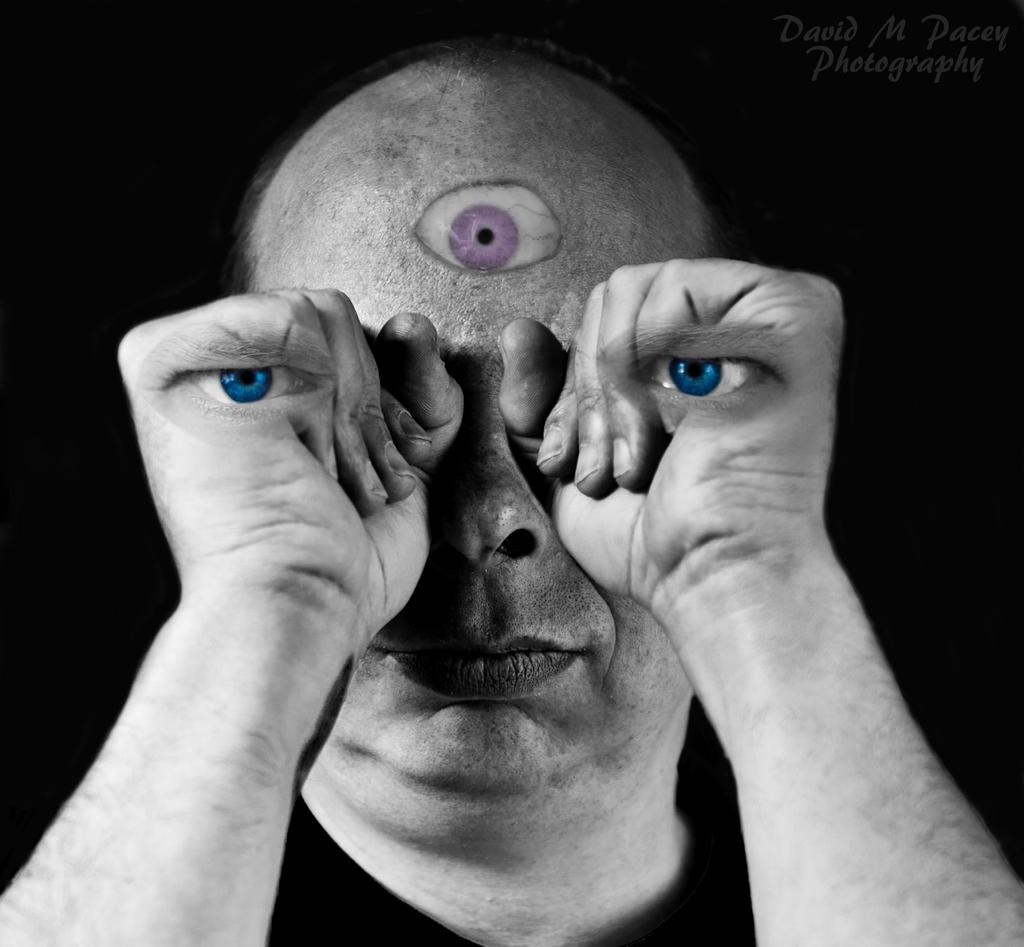What is the color scheme of the image? The image is black and white. Can you describe the person in the image? There is a man in the image. What is the man doing with his hand in the image? The man is holding his fist in front of his eye. What is an unusual feature on the man's forehead? There is an eye on the man's forehead. What is the connection between the man and the yak in the image? There is no yak present in the image, so there is no connection between the man and a yak. 